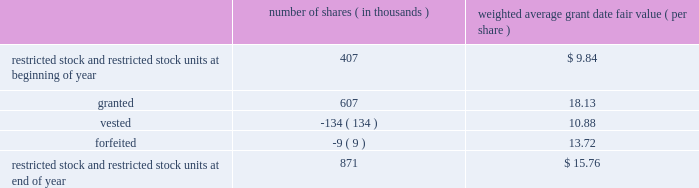Abiomed , inc .
And subsidiaries notes to consolidated financial statements 2014 ( continued ) note 8 .
Stock award plans and stock-based compensation ( continued ) restricted stock and restricted stock units the table summarizes restricted stock and restricted stock unit activity for the fiscal year ended march 31 , 2012 : number of shares ( in thousands ) weighted average grant date fair value ( per share ) .
The remaining unrecognized compensation expense for outstanding restricted stock and restricted stock units , including performance-based awards , as of march 31 , 2012 was $ 7.1 million and the weighted-average period over which this cost will be recognized is 2.2 years .
The weighted average grant-date fair value for restricted stock and restricted stock units granted during the years ended march 31 , 2012 , 2011 , and 2010 was $ 18.13 , $ 10.00 and $ 7.67 per share , respectively .
The total fair value of restricted stock and restricted stock units vested in fiscal years 2012 , 2011 , and 2010 was $ 1.5 million , $ 1.0 million and $ 0.4 million , respectively .
Performance-based awards included in the restricted stock and restricted stock units activity discussed above are certain awards granted in fiscal years 2012 , 2011 and 2010 that vest subject to certain performance-based criteria .
In june 2010 , 311000 shares of restricted stock and a performance-based award for the potential issuance of 45000 shares of common stock were issued to certain executive officers and members of senior management of the company , all of which would vest upon achievement of prescribed service milestones by the award recipients and performance milestones by the company .
During the year ended march 31 , 2011 , the company determined that it met the prescribed performance targets and a portion of these shares and stock options vested .
The remaining shares will vest upon satisfaction of prescribed service conditions by the award recipients .
During the three months ended june 30 , 2011 , the company determined that it should have been using the graded vesting method instead of the straight-line method to expense stock-based compensation for the performance-based awards issued in june 2010 .
This resulted in additional stock based compensation expense of approximately $ 0.6 million being recorded during the three months ended june 30 , 2011 that should have been recorded during the year ended march 31 , 2011 .
The company believes that the amount is not material to its march 31 , 2011 consolidated financial statements and therefore recorded the adjustment in the quarter ended june 30 , 2011 .
During the three months ended june 30 , 2011 , performance-based awards of restricted stock units for the potential issuance of 284000 shares of common stock were issued to certain executive officers and members of the senior management , all of which would vest upon achievement of prescribed service milestones by the award recipients and revenue performance milestones by the company .
As of march 31 , 2012 , the company determined that it met the prescribed targets for 184000 shares underlying these awards and it believes it is probable that the prescribed performance targets will be met for the remaining 100000 shares , and the compensation expense is being recognized accordingly .
During the year ended march 31 , 2012 , the company has recorded $ 3.3 million in stock-based compensation expense for equity awards in which the prescribed performance milestones have been achieved or are probable of being achieved .
The remaining unrecognized compensation expense related to these equity awards at march 31 , 2012 is $ 3.6 million based on the company 2019s current assessment of probability of achieving the performance milestones .
The weighted-average period over which this cost will be recognized is 2.1 years. .
What is the total value of vested shares during the fiscal year ended march 31 , 2012 , in millions? 
Computations: ((134 * 10.88) / 1000)
Answer: 1.45792. 